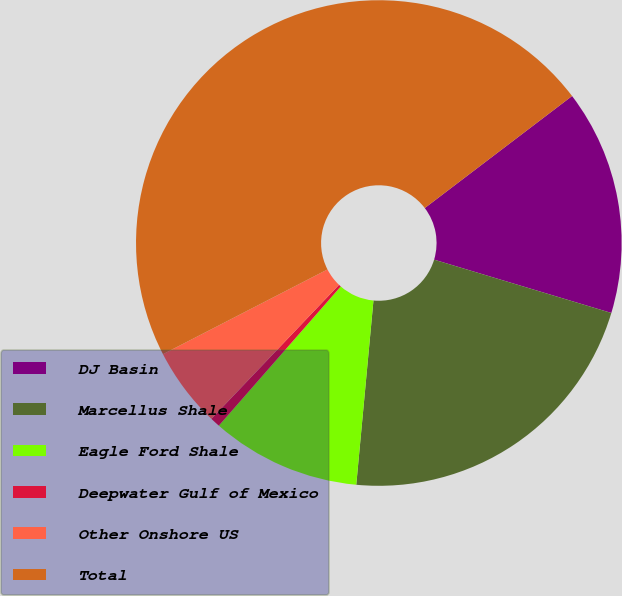Convert chart to OTSL. <chart><loc_0><loc_0><loc_500><loc_500><pie_chart><fcel>DJ Basin<fcel>Marcellus Shale<fcel>Eagle Ford Shale<fcel>Deepwater Gulf of Mexico<fcel>Other Onshore US<fcel>Total<nl><fcel>15.0%<fcel>21.83%<fcel>9.97%<fcel>0.66%<fcel>5.32%<fcel>47.22%<nl></chart> 